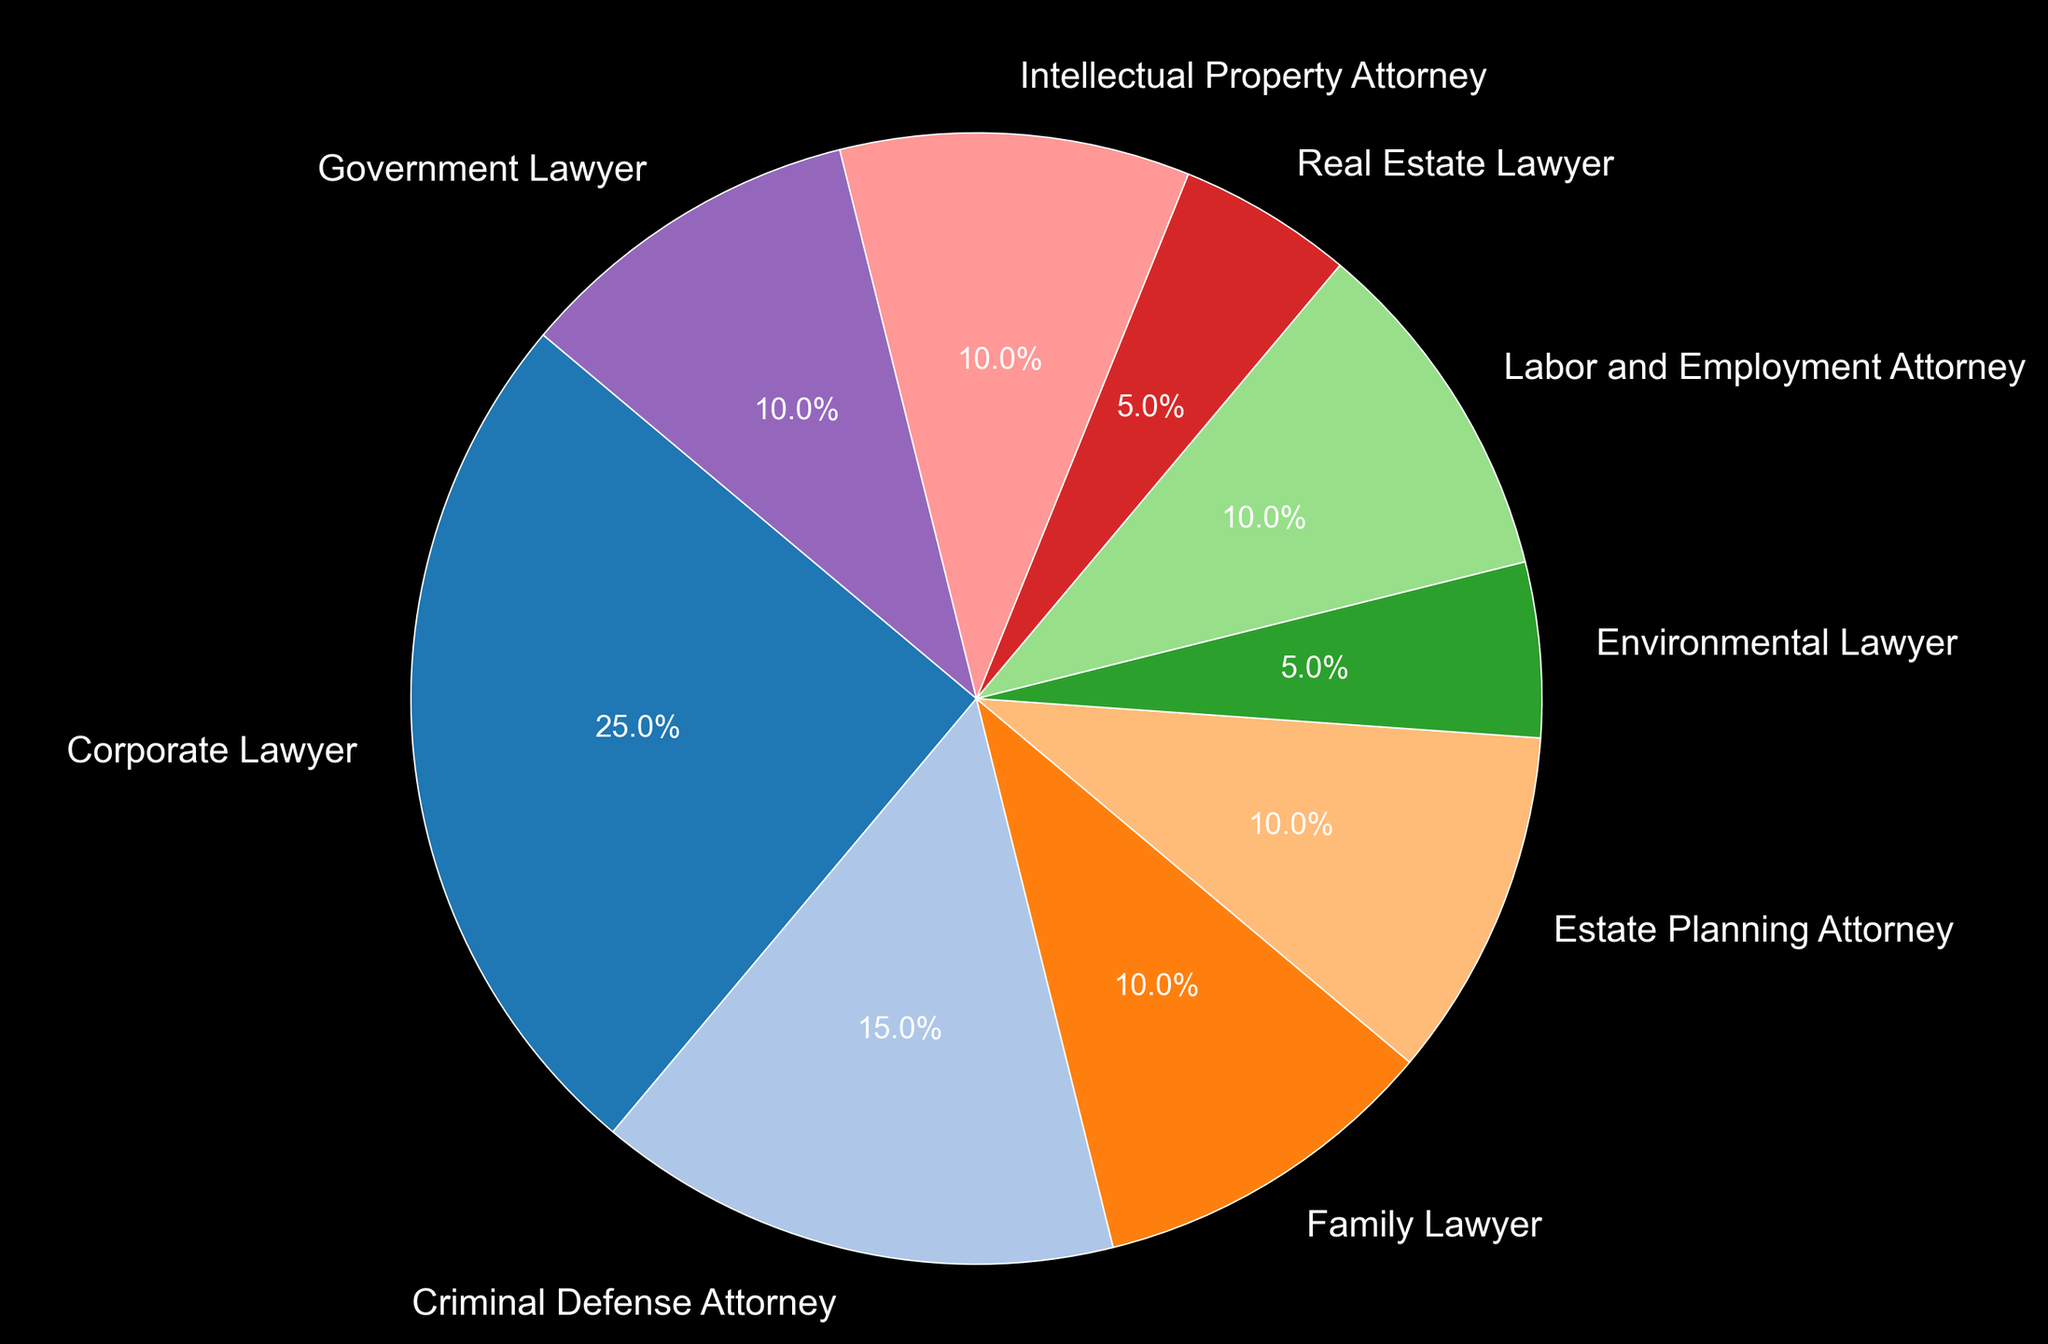What percentage of retired lawyers were Government Lawyers? Look at the segment labeled "Government Lawyer" in the pie chart, and note the percentage.
Answer: 10% Which career path has the smallest percentage of retired lawyers? Identify the segment with the smallest angle or size, and read its label.
Answer: Environmental Lawyer and Real Estate Lawyer What is the total percentage of retired lawyers who were Family Lawyers, Estate Planning Attorneys, and Real Estate Lawyers? Add the percentages of Family Lawyers (10%), Estate Planning Attorneys (10%), and Real Estate Lawyers (5%). 10% + 10% + 5% = 25%
Answer: 25% Are there more retired Corporate Lawyers than Criminal Defense Attorneys? Compare the percentages of Corporate Lawyers (25%) with Criminal Defense Attorneys (15%).
Answer: Yes How much larger is the percentage of Corporate Lawyers compared to Environmental Lawyers? Subtract the percentage of Environmental Lawyers (5%) from that of Corporate Lawyers (25%). 25% - 5% = 20%
Answer: 20% Which career path has the highest percentage of retired lawyers and what is it? Identify the largest segment in the pie chart and read its label and percentage.
Answer: Corporate Lawyer, 25% What is the combined percentage of retired Labor and Employment Attorneys and Intellectual Property Attorneys? Add the percentages of Labor and Employment Attorneys (10%) and Intellectual Property Attorneys (10%). 10% + 10% = 20%
Answer: 20% If you combine the percentages of Family Lawyers, Estate Planning Attorneys, and Labor and Employment Attorneys, is the total greater than 30%? Add their percentages: Family Lawyers (10%), Estate Planning Attorneys (10%), and Labor and Employment Attorneys (10%). Then check if the sum is greater than 30%. 10% + 10% + 10% = 30%
Answer: No Which two career paths have the same percentage of retired lawyers, and what is that percentage? Look for segments with equal size/angle and note their labels and percentage.
Answer: Family Lawyer and Estate Planning Attorney, 10% 